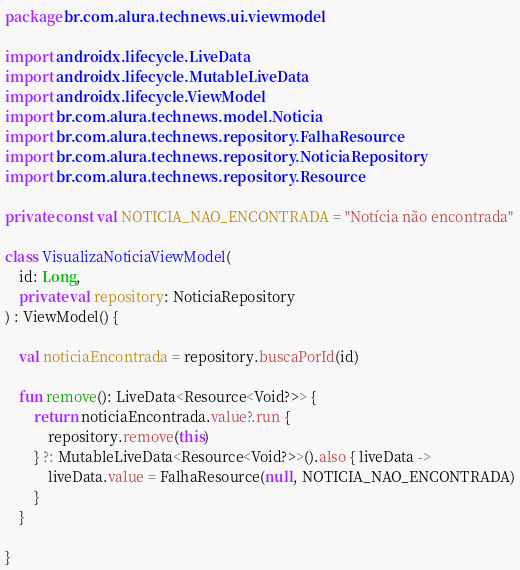Convert code to text. <code><loc_0><loc_0><loc_500><loc_500><_Kotlin_>package br.com.alura.technews.ui.viewmodel

import androidx.lifecycle.LiveData
import androidx.lifecycle.MutableLiveData
import androidx.lifecycle.ViewModel
import br.com.alura.technews.model.Noticia
import br.com.alura.technews.repository.FalhaResource
import br.com.alura.technews.repository.NoticiaRepository
import br.com.alura.technews.repository.Resource

private const val NOTICIA_NAO_ENCONTRADA = "Notícia não encontrada"

class VisualizaNoticiaViewModel(
    id: Long,
    private val repository: NoticiaRepository
) : ViewModel() {

    val noticiaEncontrada = repository.buscaPorId(id)

    fun remove(): LiveData<Resource<Void?>> {
        return noticiaEncontrada.value?.run {
            repository.remove(this)
        } ?: MutableLiveData<Resource<Void?>>().also { liveData ->
            liveData.value = FalhaResource(null, NOTICIA_NAO_ENCONTRADA)
        }
    }

}</code> 